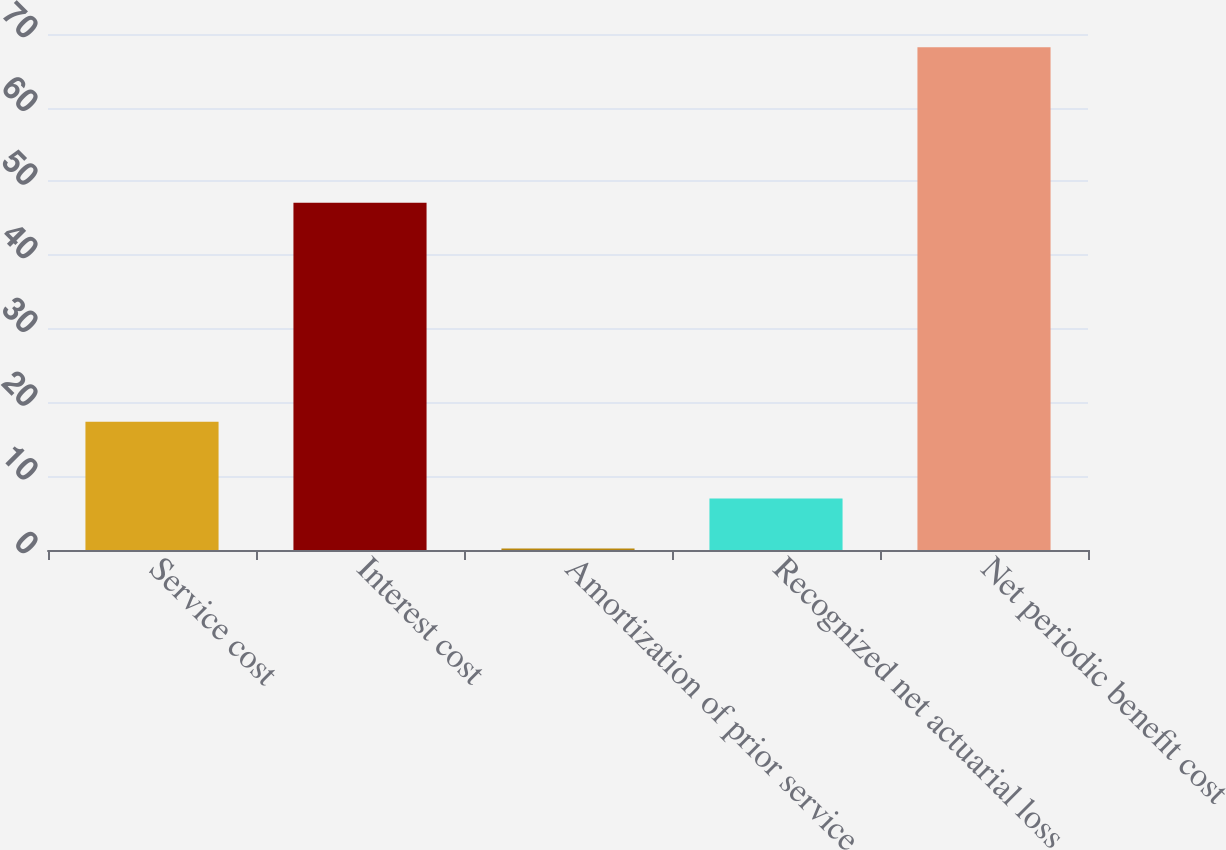<chart> <loc_0><loc_0><loc_500><loc_500><bar_chart><fcel>Service cost<fcel>Interest cost<fcel>Amortization of prior service<fcel>Recognized net actuarial loss<fcel>Net periodic benefit cost<nl><fcel>17.4<fcel>47.1<fcel>0.2<fcel>7<fcel>68.2<nl></chart> 